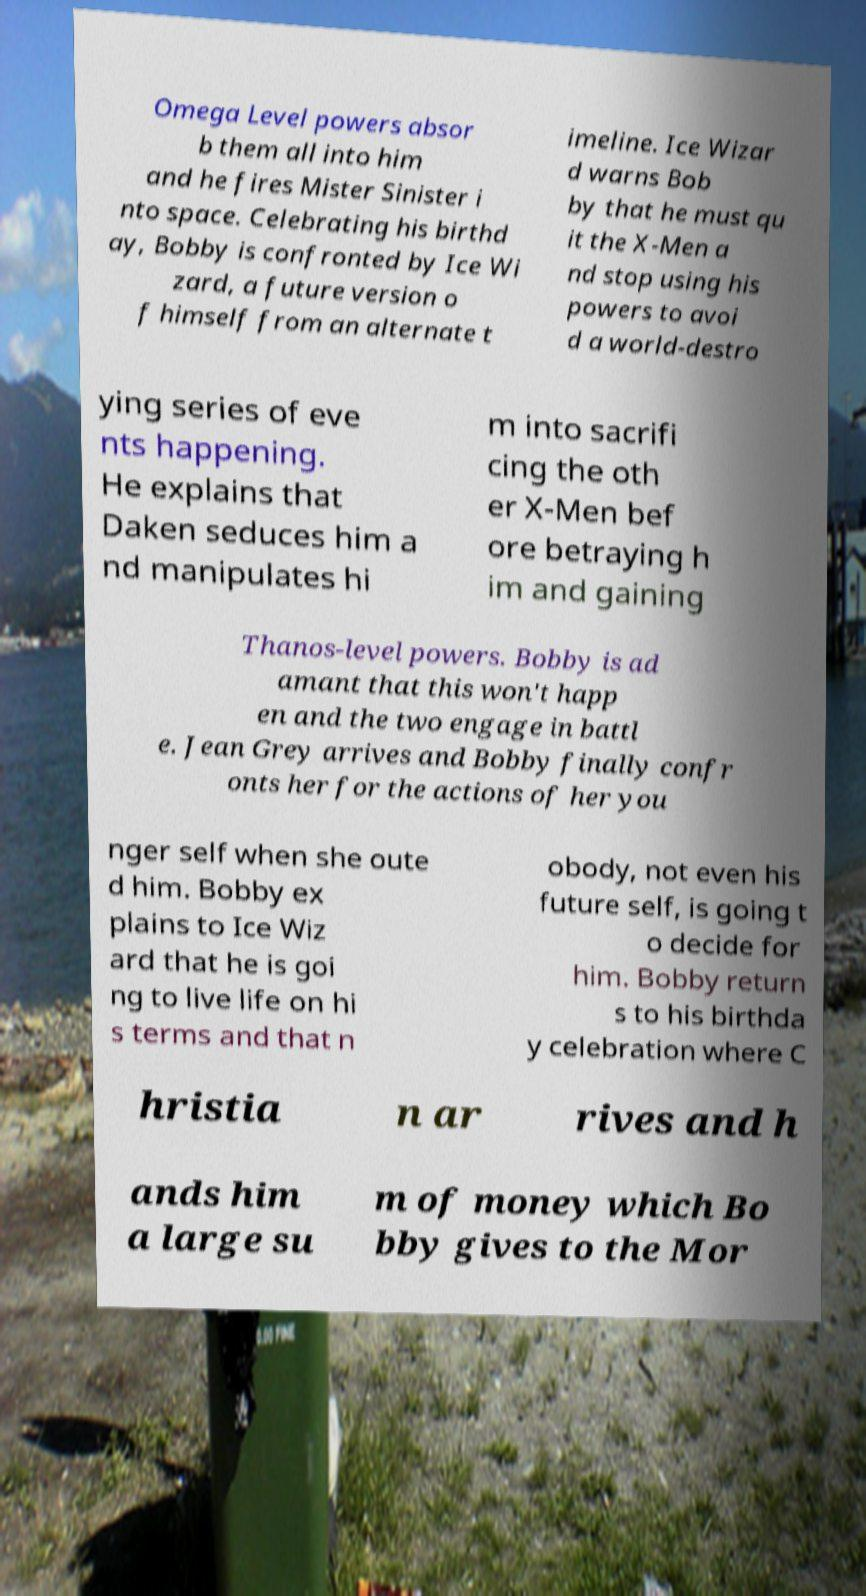Please identify and transcribe the text found in this image. Omega Level powers absor b them all into him and he fires Mister Sinister i nto space. Celebrating his birthd ay, Bobby is confronted by Ice Wi zard, a future version o f himself from an alternate t imeline. Ice Wizar d warns Bob by that he must qu it the X-Men a nd stop using his powers to avoi d a world-destro ying series of eve nts happening. He explains that Daken seduces him a nd manipulates hi m into sacrifi cing the oth er X-Men bef ore betraying h im and gaining Thanos-level powers. Bobby is ad amant that this won't happ en and the two engage in battl e. Jean Grey arrives and Bobby finally confr onts her for the actions of her you nger self when she oute d him. Bobby ex plains to Ice Wiz ard that he is goi ng to live life on hi s terms and that n obody, not even his future self, is going t o decide for him. Bobby return s to his birthda y celebration where C hristia n ar rives and h ands him a large su m of money which Bo bby gives to the Mor 